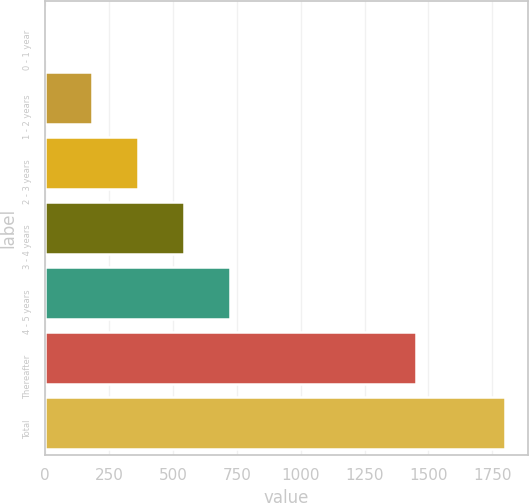<chart> <loc_0><loc_0><loc_500><loc_500><bar_chart><fcel>0 - 1 year<fcel>1 - 2 years<fcel>2 - 3 years<fcel>3 - 4 years<fcel>4 - 5 years<fcel>Thereafter<fcel>Total<nl><fcel>4<fcel>183.5<fcel>363<fcel>542.5<fcel>722<fcel>1453<fcel>1799<nl></chart> 